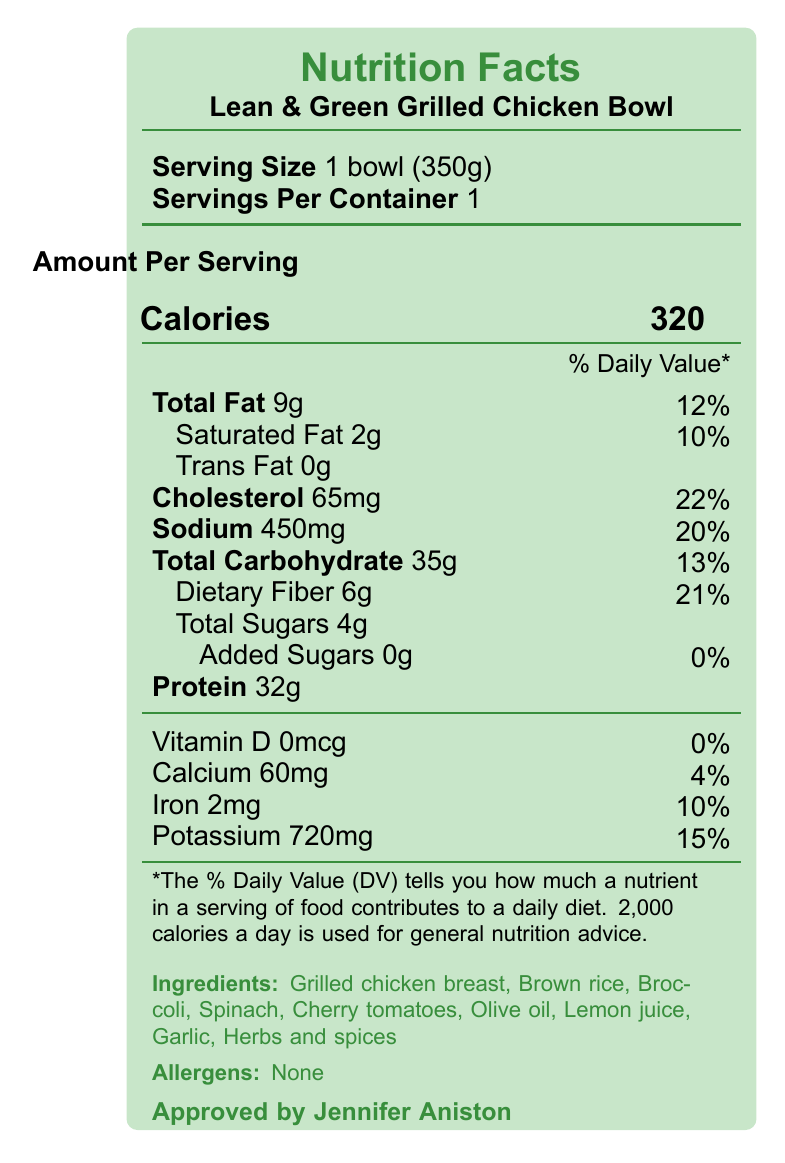What is the serving size for the Lean & Green Grilled Chicken Bowl? The document specifies that the serving size is 1 bowl, which weighs 350 grams.
Answer: 1 bowl (350g) How many calories are in a serving of the Lean & Green Grilled Chicken Bowl? The document lists "Calories 320" under the nutrition facts.
Answer: 320 What percentage of the daily value for dietary fiber does this meal provide? The document shows that the dietary fiber content is 6g, which corresponds to 21% of the daily value.
Answer: 21% What ingredients are listed for the Lean & Green Grilled Chicken Bowl? The ingredients are clearly listed at the bottom of the document.
Answer: Grilled chicken breast, Brown rice, Broccoli, Spinach, Cherry tomatoes, Olive oil, Lemon juice, Garlic, Herbs and spices What is the daily value percentage for sodium? The document states that the sodium content is 450mg, which is 20% of the daily value.
Answer: 20% How much protein does this meal contain? The document lists "Protein 32g" as part of the nutrition facts.
Answer: 32g Which of the following is not an ingredient in the Lean & Green Grilled Chicken Bowl? A. Broccoli B. Carrots C. Spinach D. Cherry tomatoes The list of ingredients does not include carrots.
Answer: B. Carrots What is the main source of endorsement mentioned in the document? A. A famous chef B. A nutritionist C. Jennifer Aniston D. A fitness trainer The document mentions that the meal is "Approved by Jennifer Aniston".
Answer: C. Jennifer Aniston Is this meal high in protein? With 32 grams of protein per serving, this meal qualifies as high-protein.
Answer: Yes Summarize the main idea of the document. The main idea is to highlight the nutritional benefits and endorsement of the Lean & Green Grilled Chicken Bowl, emphasizing its suitability for a healthy lifestyle.
Answer: The document provides detailed nutrition facts for the Lean & Green Grilled Chicken Bowl, which is endorsed by Jennifer Aniston and advertised as a low-calorie, high-protein, and gluten-free meal. It includes information about serving size, calorie content, nutrient percentages, ingredients, allergens, and preparation instructions. How does this bowl align with a gluten-free diet? The dietary tag specifies "Gluten-free", and none of the ingredients listed contain gluten.
Answer: The ingredients listed do not contain any gluten-containing items, indicating that the meal is suitable for a gluten-free diet. What is the shelf life of the prepared meal when refrigerated? The meal prep details note that it has a shelf life of 3 days when refrigerated.
Answer: 3 days Does the Lean & Green Grilled Chicken Bowl contain any trans fats? The nutrition facts clearly indicate "Trans Fat 0g".
Answer: No How many grams of added sugars are in this meal? The document lists "Added Sugars 0g" under the nutrition facts.
Answer: 0g Does this meal contain allergens? The document explicitly states "Allergens: None".
Answer: No What is the vitamin D content in the Lean & Green Grilled Chicken Bowl? The nutrition facts show "Vitamin D 0mcg".
Answer: 0mcg What is the preparation method for this meal? The meal prep details specify the preparation method as "Freshly prepared and vacuum-sealed".
Answer: Freshly prepared and vacuum-sealed What is the daily value percentage for calcium provided by this meal? The document shows "Calcium 60mg", which is 4% of the daily value.
Answer: 4% Who is the target audience for this document? The document's content and endorsement suggest it is aimed at individuals interested in maintaining a healthy lifestyle.
Answer: Healthy lifestyle enthusiasts What are the heating instructions for the Lean & Green Grilled Chicken Bowl? The heating instructions are found in the meal prep details.
Answer: Microwave for 2-3 minutes or heat in oven at 350°F for 10-12 minutes What is Jennifer Aniston's involvement in this meal? The document mentions that the meal is "Approved by Jennifer Aniston" but does not provide details on her specific involvement.
Answer: Cannot be determined 